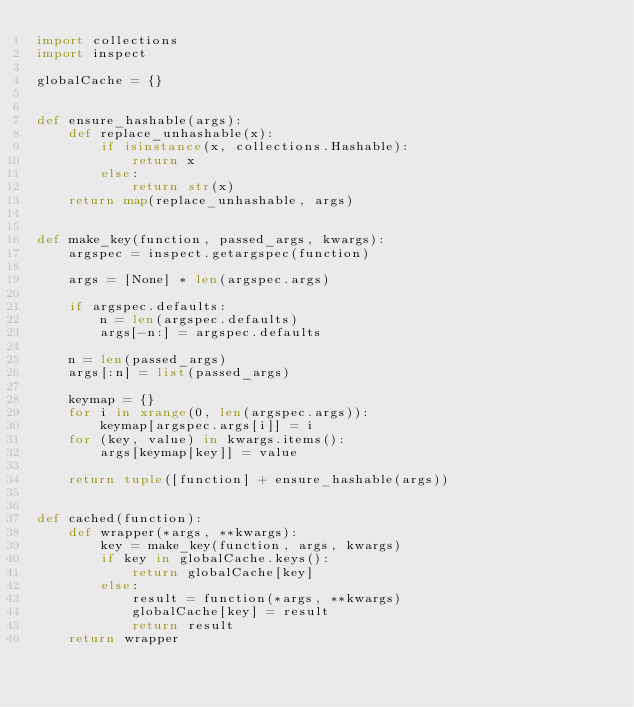<code> <loc_0><loc_0><loc_500><loc_500><_Python_>import collections
import inspect

globalCache = {}


def ensure_hashable(args):
    def replace_unhashable(x):
        if isinstance(x, collections.Hashable):
            return x
        else:
            return str(x)
    return map(replace_unhashable, args)


def make_key(function, passed_args, kwargs):
    argspec = inspect.getargspec(function)

    args = [None] * len(argspec.args)

    if argspec.defaults:
        n = len(argspec.defaults)
        args[-n:] = argspec.defaults

    n = len(passed_args)
    args[:n] = list(passed_args)

    keymap = {}
    for i in xrange(0, len(argspec.args)):
        keymap[argspec.args[i]] = i
    for (key, value) in kwargs.items():
        args[keymap[key]] = value

    return tuple([function] + ensure_hashable(args))


def cached(function):
    def wrapper(*args, **kwargs):
        key = make_key(function, args, kwargs)
        if key in globalCache.keys():
            return globalCache[key]
        else:
            result = function(*args, **kwargs)
            globalCache[key] = result
            return result
    return wrapper
</code> 